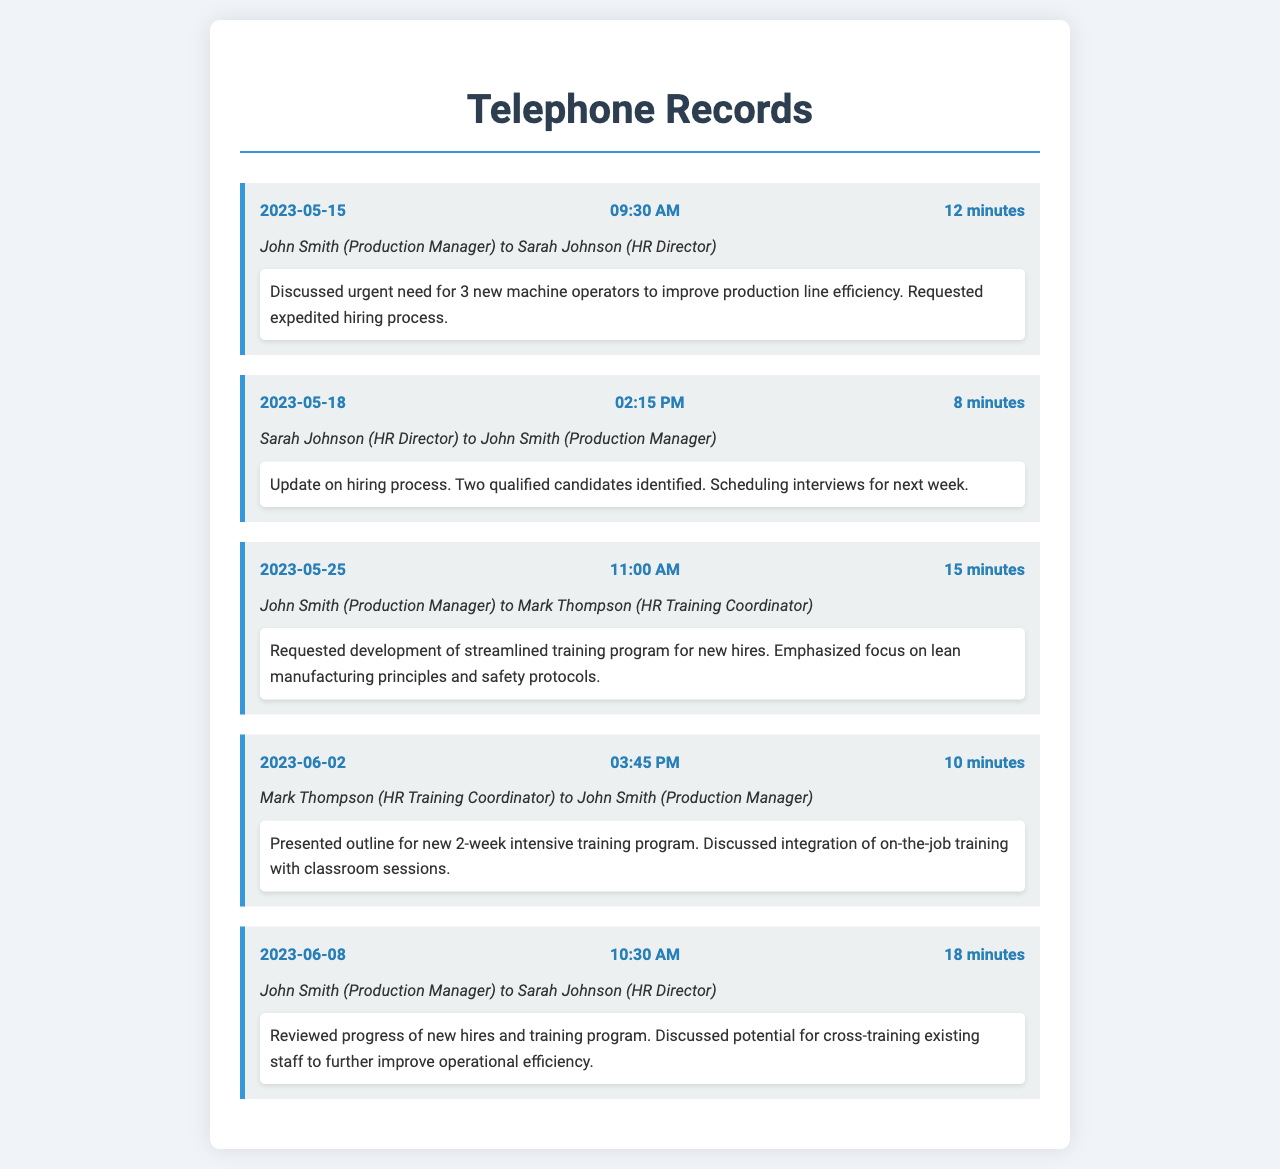What was the date of the first call? The first call is dated 2023-05-15, which is the earliest date mentioned in the call records.
Answer: 2023-05-15 Who was the HR Director in the calls? The HR Director mentioned in the calls is Sarah Johnson, who participated in multiple conversations.
Answer: Sarah Johnson How many new machine operators were discussed in the first call? The first call specifically discussed the urgent need for three new machine operators to improve efficiency.
Answer: 3 What is the duration of the longest call? The duration of the longest call was 18 minutes, based on the document's call duration records.
Answer: 18 minutes What training principles were emphasized for the new hires? The call with Mark Thompson highlighted the focus on lean manufacturing principles and safety protocols for the training program.
Answer: Lean manufacturing principles and safety protocols What type of training program was discussed in the call on June 2? The call on June 2 discussed a new 2-week intensive training program for new hires, as presented by Mark Thompson.
Answer: 2-week intensive training program How many qualified candidates were identified by Sarah Johnson? During the second call, Sarah Johnson mentioned that two qualified candidates had been identified for interviews.
Answer: 2 What was the overall goal discussed in the calls? The calls primarily focused on improving operational efficiency through new hires and better training programs in production.
Answer: Improving operational efficiency 